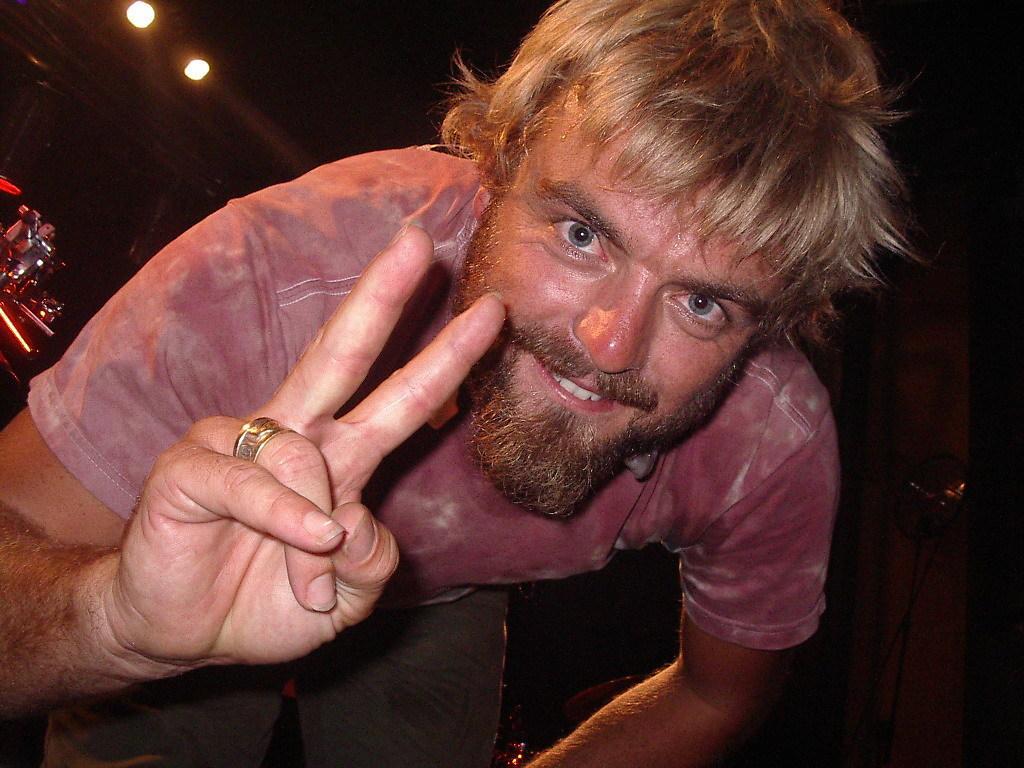Can you describe this image briefly? In this picture there is a person wearing pink shirt is showing v sign and there are few lights and some other objects in the background. 